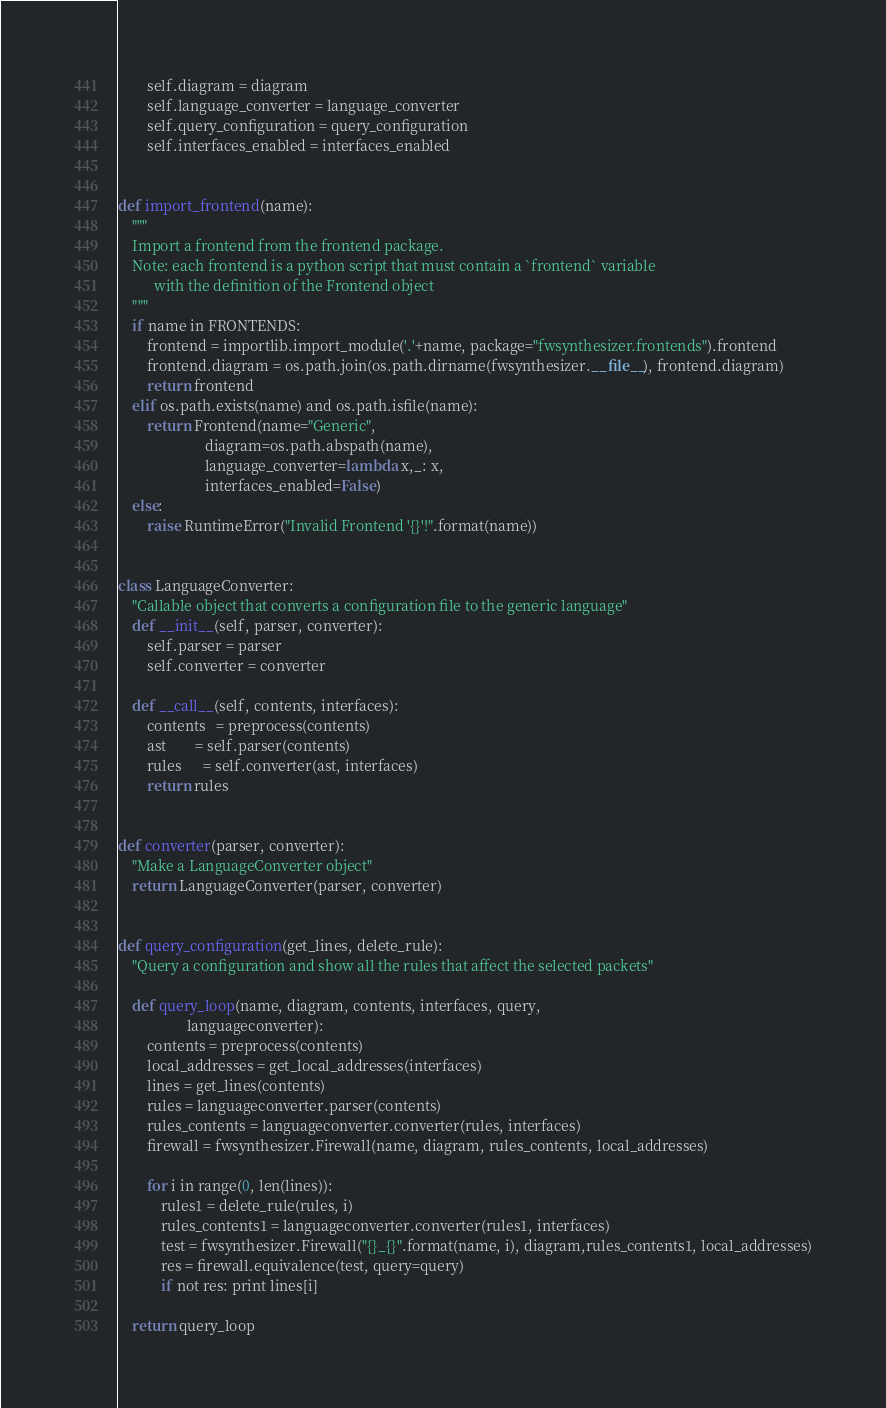<code> <loc_0><loc_0><loc_500><loc_500><_Python_>        self.diagram = diagram
        self.language_converter = language_converter
        self.query_configuration = query_configuration
        self.interfaces_enabled = interfaces_enabled


def import_frontend(name):
    """
    Import a frontend from the frontend package.
    Note: each frontend is a python script that must contain a `frontend` variable
          with the definition of the Frontend object
    """
    if name in FRONTENDS:
        frontend = importlib.import_module('.'+name, package="fwsynthesizer.frontends").frontend
        frontend.diagram = os.path.join(os.path.dirname(fwsynthesizer.__file__), frontend.diagram)
        return frontend
    elif os.path.exists(name) and os.path.isfile(name):
        return Frontend(name="Generic",
                        diagram=os.path.abspath(name),
                        language_converter=lambda x,_: x,
                        interfaces_enabled=False)
    else:
        raise RuntimeError("Invalid Frontend '{}'!".format(name))


class LanguageConverter:
    "Callable object that converts a configuration file to the generic language"
    def __init__(self, parser, converter):
        self.parser = parser
        self.converter = converter

    def __call__(self, contents, interfaces):
        contents   = preprocess(contents)
        ast        = self.parser(contents)
        rules      = self.converter(ast, interfaces)
        return rules


def converter(parser, converter):
    "Make a LanguageConverter object"
    return LanguageConverter(parser, converter)


def query_configuration(get_lines, delete_rule):
    "Query a configuration and show all the rules that affect the selected packets"

    def query_loop(name, diagram, contents, interfaces, query,
                   languageconverter):
        contents = preprocess(contents)
        local_addresses = get_local_addresses(interfaces)
        lines = get_lines(contents)
        rules = languageconverter.parser(contents)
        rules_contents = languageconverter.converter(rules, interfaces)
        firewall = fwsynthesizer.Firewall(name, diagram, rules_contents, local_addresses)

        for i in range(0, len(lines)):
            rules1 = delete_rule(rules, i)
            rules_contents1 = languageconverter.converter(rules1, interfaces)
            test = fwsynthesizer.Firewall("{}_{}".format(name, i), diagram,rules_contents1, local_addresses)
            res = firewall.equivalence(test, query=query)
            if not res: print lines[i]

    return query_loop
</code> 